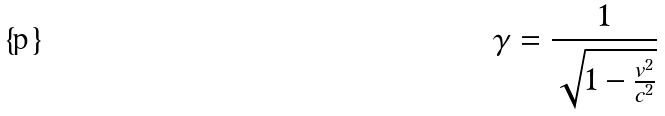<formula> <loc_0><loc_0><loc_500><loc_500>\gamma = \frac { 1 } { \sqrt { 1 - \frac { v ^ { 2 } } { c ^ { 2 } } } }</formula> 